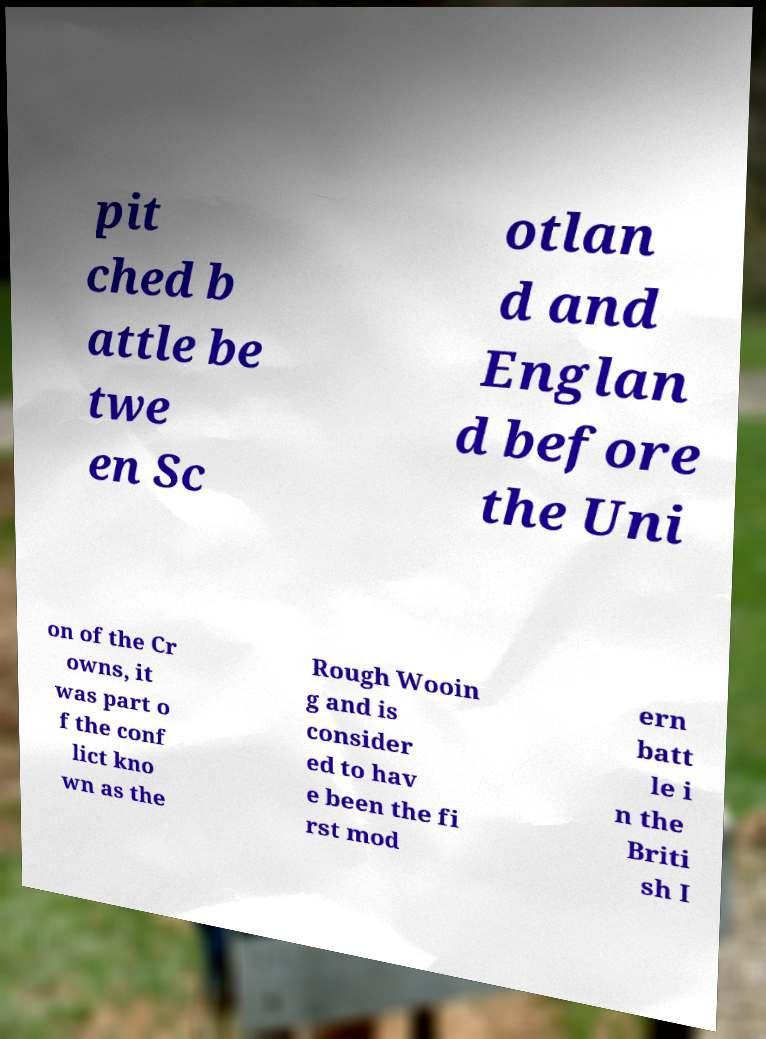Please read and relay the text visible in this image. What does it say? pit ched b attle be twe en Sc otlan d and Englan d before the Uni on of the Cr owns, it was part o f the conf lict kno wn as the Rough Wooin g and is consider ed to hav e been the fi rst mod ern batt le i n the Briti sh I 